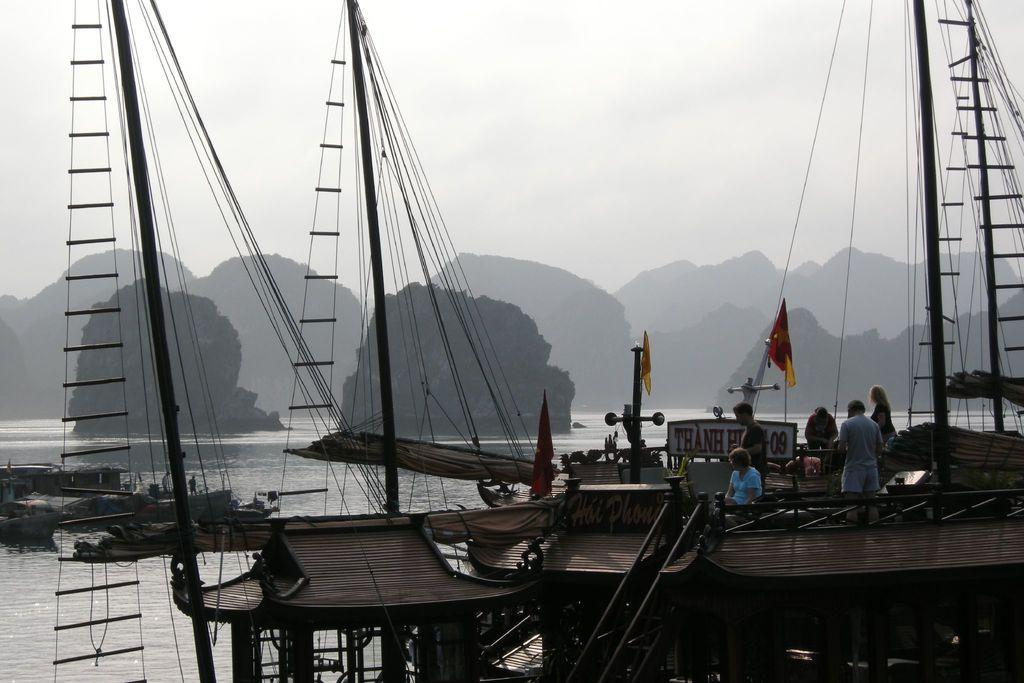What is the main subject of the image? The main subject of the image is boats. What can be seen on the boats? Flags are present on the boats, and there are people on the boats. What is visible in the background of the image? The background of the image includes sky, clouds, a hill, trees, and water. Are there any other boats visible in the image? Yes, there are additional boats in the background. What type of wool is being spun by the person on the boat? There is no wool or spinning activity present in the image; it features boats with flags and people on them. 